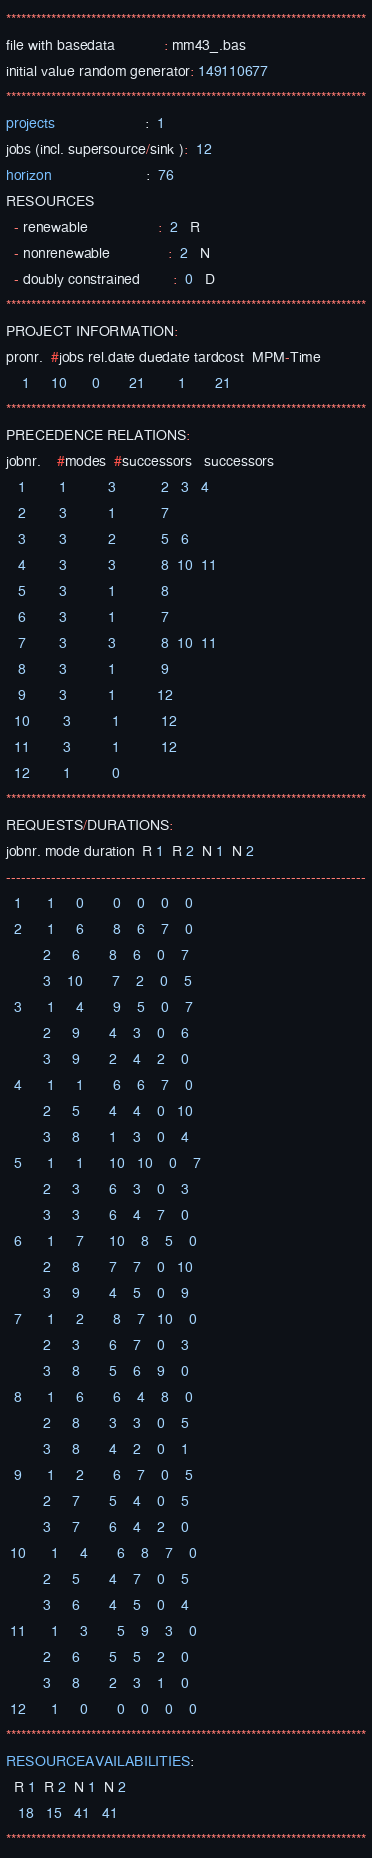Convert code to text. <code><loc_0><loc_0><loc_500><loc_500><_ObjectiveC_>************************************************************************
file with basedata            : mm43_.bas
initial value random generator: 149110677
************************************************************************
projects                      :  1
jobs (incl. supersource/sink ):  12
horizon                       :  76
RESOURCES
  - renewable                 :  2   R
  - nonrenewable              :  2   N
  - doubly constrained        :  0   D
************************************************************************
PROJECT INFORMATION:
pronr.  #jobs rel.date duedate tardcost  MPM-Time
    1     10      0       21        1       21
************************************************************************
PRECEDENCE RELATIONS:
jobnr.    #modes  #successors   successors
   1        1          3           2   3   4
   2        3          1           7
   3        3          2           5   6
   4        3          3           8  10  11
   5        3          1           8
   6        3          1           7
   7        3          3           8  10  11
   8        3          1           9
   9        3          1          12
  10        3          1          12
  11        3          1          12
  12        1          0        
************************************************************************
REQUESTS/DURATIONS:
jobnr. mode duration  R 1  R 2  N 1  N 2
------------------------------------------------------------------------
  1      1     0       0    0    0    0
  2      1     6       8    6    7    0
         2     6       8    6    0    7
         3    10       7    2    0    5
  3      1     4       9    5    0    7
         2     9       4    3    0    6
         3     9       2    4    2    0
  4      1     1       6    6    7    0
         2     5       4    4    0   10
         3     8       1    3    0    4
  5      1     1      10   10    0    7
         2     3       6    3    0    3
         3     3       6    4    7    0
  6      1     7      10    8    5    0
         2     8       7    7    0   10
         3     9       4    5    0    9
  7      1     2       8    7   10    0
         2     3       6    7    0    3
         3     8       5    6    9    0
  8      1     6       6    4    8    0
         2     8       3    3    0    5
         3     8       4    2    0    1
  9      1     2       6    7    0    5
         2     7       5    4    0    5
         3     7       6    4    2    0
 10      1     4       6    8    7    0
         2     5       4    7    0    5
         3     6       4    5    0    4
 11      1     3       5    9    3    0
         2     6       5    5    2    0
         3     8       2    3    1    0
 12      1     0       0    0    0    0
************************************************************************
RESOURCEAVAILABILITIES:
  R 1  R 2  N 1  N 2
   18   15   41   41
************************************************************************
</code> 